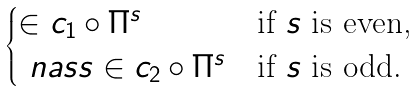Convert formula to latex. <formula><loc_0><loc_0><loc_500><loc_500>\begin{cases} \in c _ { 1 } \circ \Pi ^ { s } & \text {if $s$ is even,} \\ \ n a s s \in c _ { 2 } \circ \Pi ^ { s } & \text {if $s$ is odd.} \end{cases}</formula> 